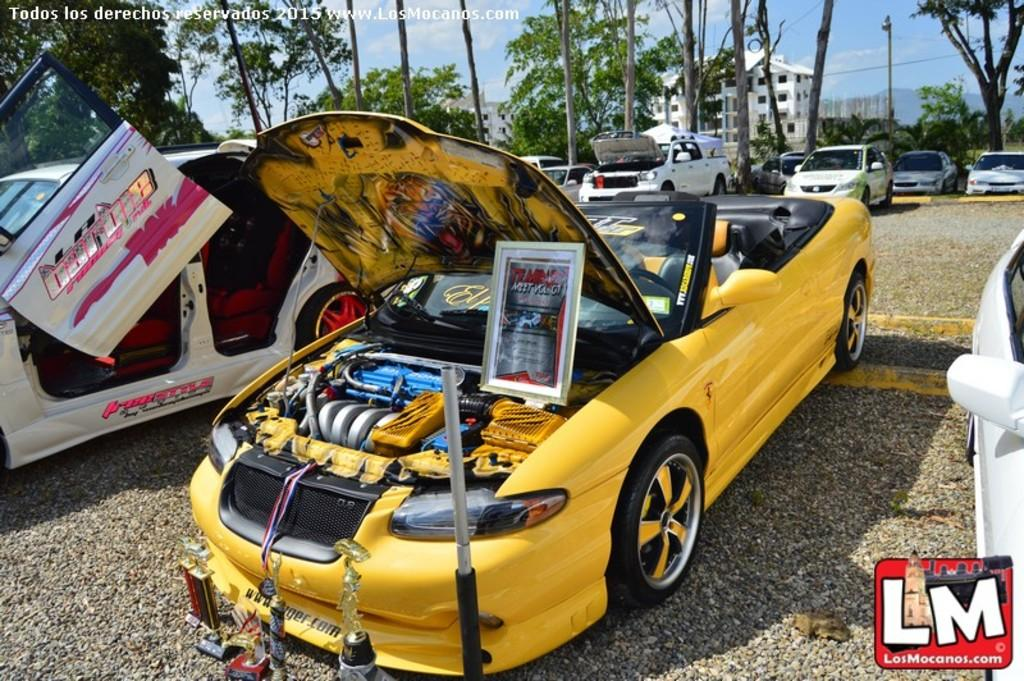What can be seen on the road in the image? There are cars parked on the road in the image. What type of natural elements are visible in the background of the image? There are trees visible in the background of the image. What type of man-made structures can be seen in the background of the image? There are buildings in the background of the image. What part of the natural environment is visible in the background of the image? The sky is visible in the background of the image. What type of prose is being recited by the trees in the image? There is no prose being recited by the trees in the image, as trees do not have the ability to recite prose. What button is being pushed by the buildings in the image? There is no button being pushed by the buildings in the image, as buildings are inanimate objects and do not have the ability to push buttons. 